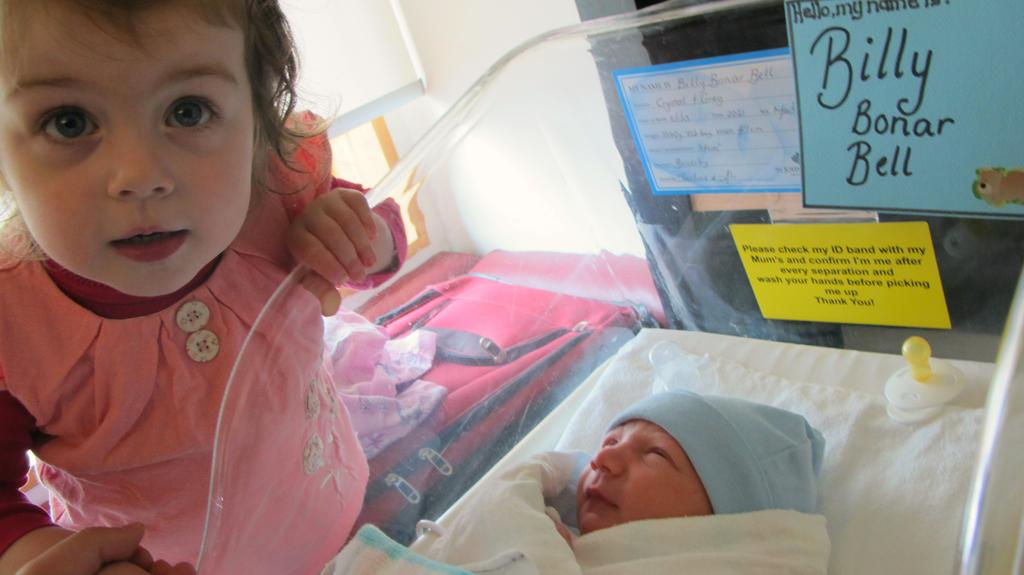What is the main subject of the image? There is a baby sleeping in a crib in the image. What can be seen on the left side of the image? There is a girl standing on the left side of the image. What type of objects are visible in the image? There are boards, a wall, a bag, a cloth, and a zipper visible in the image. What type of cap is the baby wearing in the image? The baby is not wearing a cap in the image; they are sleeping in a crib. Can you describe the baby's back in the image? The baby is lying down in the crib, so their back is not visible in the image. 